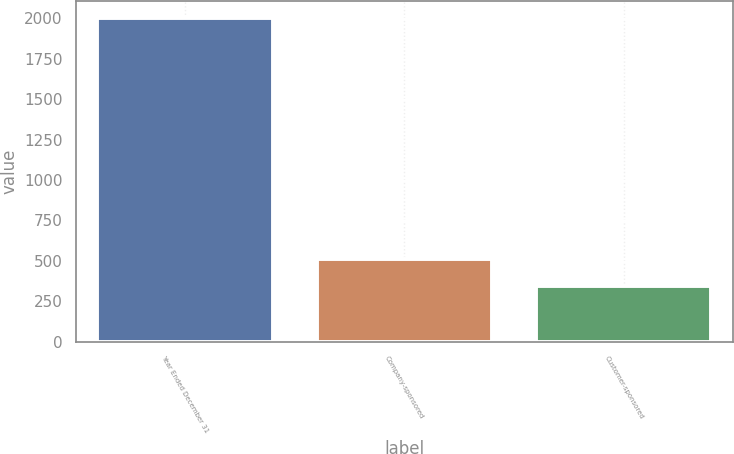Convert chart to OTSL. <chart><loc_0><loc_0><loc_500><loc_500><bar_chart><fcel>Year Ended December 31<fcel>Company-sponsored<fcel>Customer-sponsored<nl><fcel>2005<fcel>509.2<fcel>343<nl></chart> 